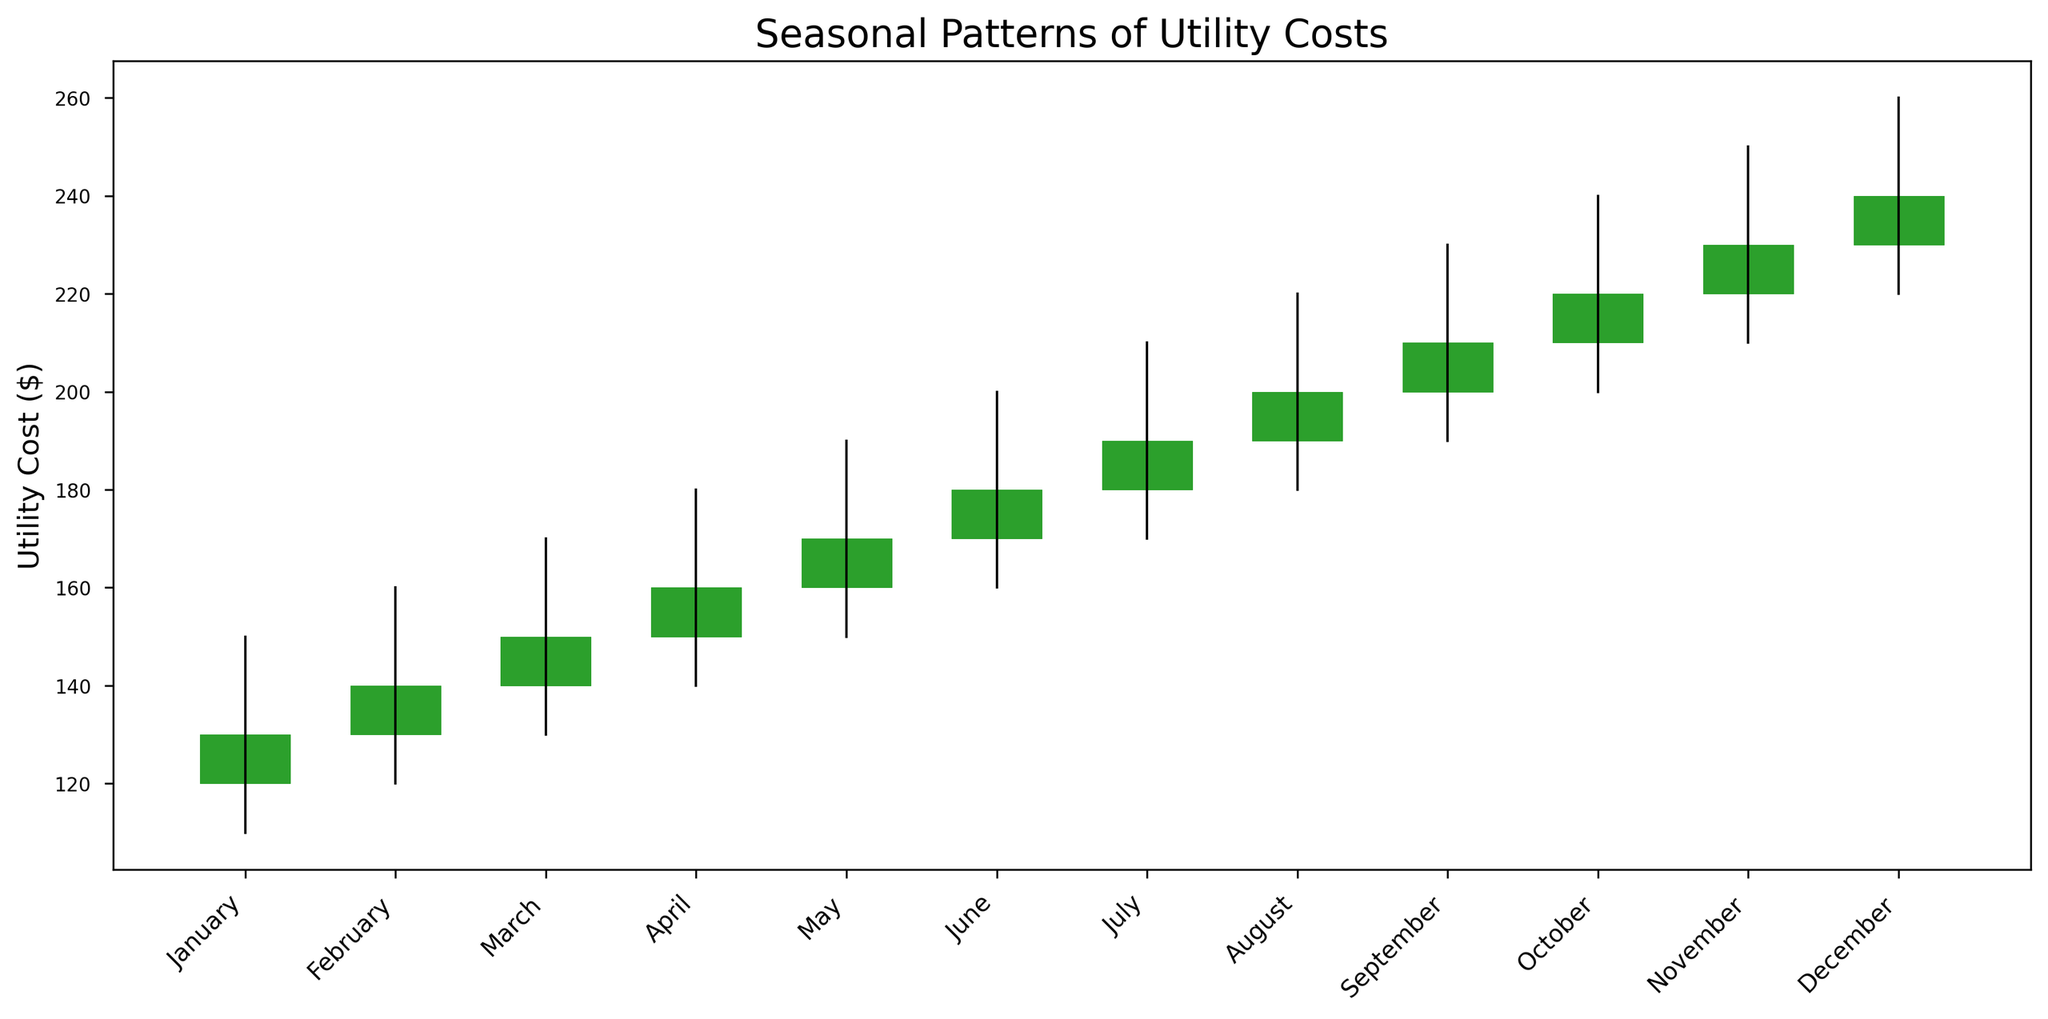Which month has the highest utility cost? November and December both have the highest closing cost of $240.
Answer: November and December In which month does the utility cost experience the greatest increase from opening to closing? October has an increase from an open of $210 to a close of $220, which is a 10 dollar increase.
Answer: October What is the average closing utility cost for the first quarter (January to March)? The closing costs for January, February, and March are 130, 140, and 150 respectively, so the average is (130 + 140 + 150) / 3 = 420 / 3 = 140.
Answer: 140 Which month has the lowest recorded utility cost, and what is that cost? January has the lowest recorded low value at $110.
Answer: January, 110 Compare the opening and closing prices in July. Which one is higher? July's opening price is $180, and the closing price is $190, so the closing price is higher.
Answer: Closing price In which month do the utility costs have the smallest range between the high and low values? January has the smallest range with a high of $150 and a low of $110, resulting in a range of $150 - $110 = $40.
Answer: January What is the sum of the closing costs for the months of June, July, and August? The closing costs for June, July, and August are 180, 190, and 200 respectively. The sum is 180 + 190 + 200 = 570.
Answer: 570 Which months have the same opening price? No two months have the same opening price based on the given data.
Answer: None By how much does the highest utility cost in December exceed the lowest utility cost in January? The highest cost in December is $260, and the lowest cost in January is $110, so the difference is $260 - $110 = $150.
Answer: 150 What is the trend in closing utility costs from January to December? Closing utility costs increase consistently from $130 in January to $240 in December.
Answer: Increasing 